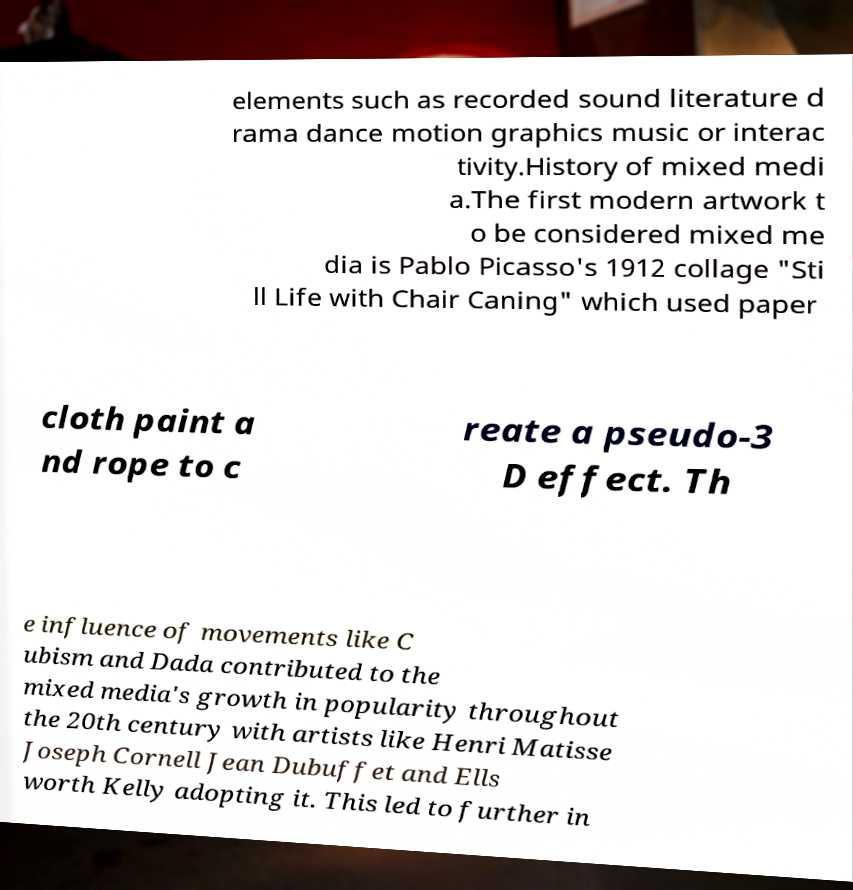There's text embedded in this image that I need extracted. Can you transcribe it verbatim? elements such as recorded sound literature d rama dance motion graphics music or interac tivity.History of mixed medi a.The first modern artwork t o be considered mixed me dia is Pablo Picasso's 1912 collage "Sti ll Life with Chair Caning" which used paper cloth paint a nd rope to c reate a pseudo-3 D effect. Th e influence of movements like C ubism and Dada contributed to the mixed media's growth in popularity throughout the 20th century with artists like Henri Matisse Joseph Cornell Jean Dubuffet and Ells worth Kelly adopting it. This led to further in 